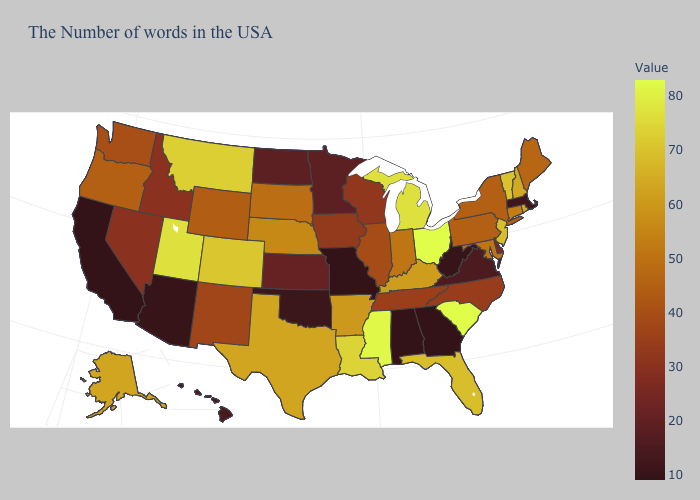Which states have the highest value in the USA?
Write a very short answer. South Carolina, Ohio. Which states hav the highest value in the MidWest?
Give a very brief answer. Ohio. Does Massachusetts have a higher value than Louisiana?
Be succinct. No. Does the map have missing data?
Short answer required. No. Which states have the lowest value in the USA?
Keep it brief. Georgia, Alabama, Missouri, California. Does Kansas have the lowest value in the USA?
Be succinct. No. 